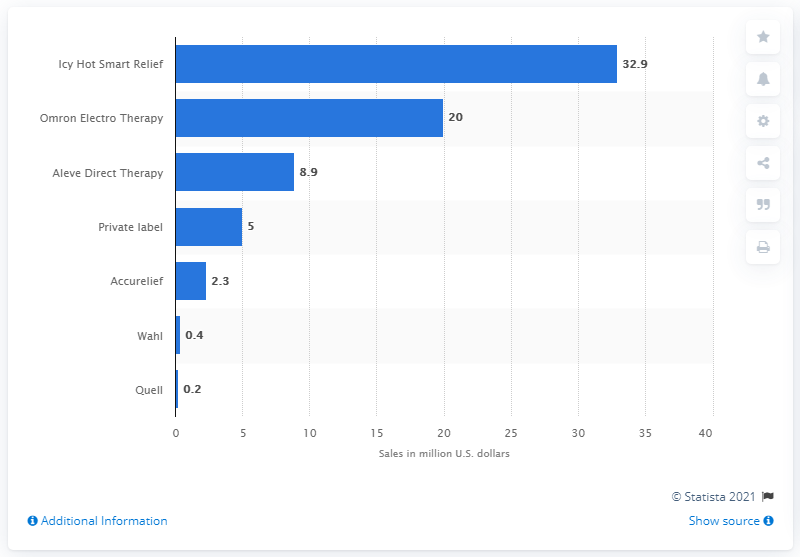Point out several critical features in this image. In the United States in 2016, Icy Hot Smart Relief sold 32.9 units of the product. In 2016, the leading U.S. electrotherapy device brand was Icy Hot Smart Relief. 